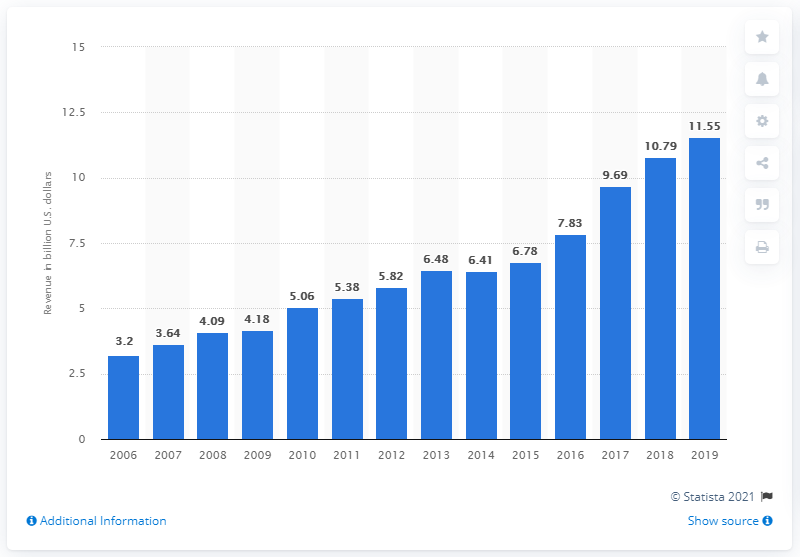Give some essential details in this illustration. Live Nation's revenue from the previous year was 10.79.. 